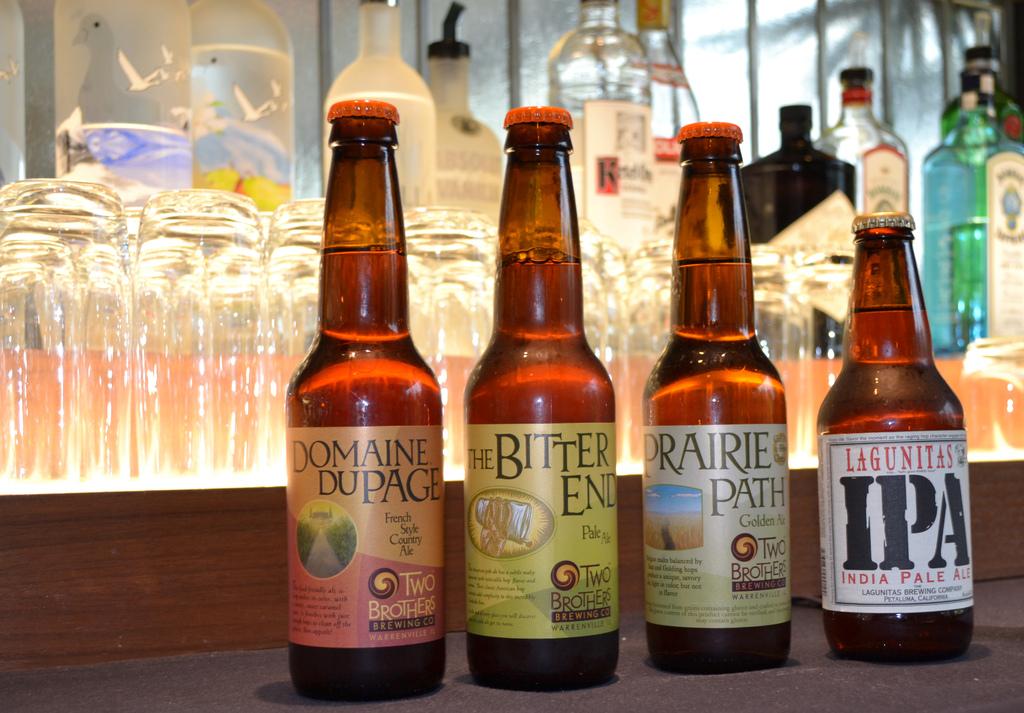What is the beer farthest left called?
Your answer should be very brief. Domaine dupage. 